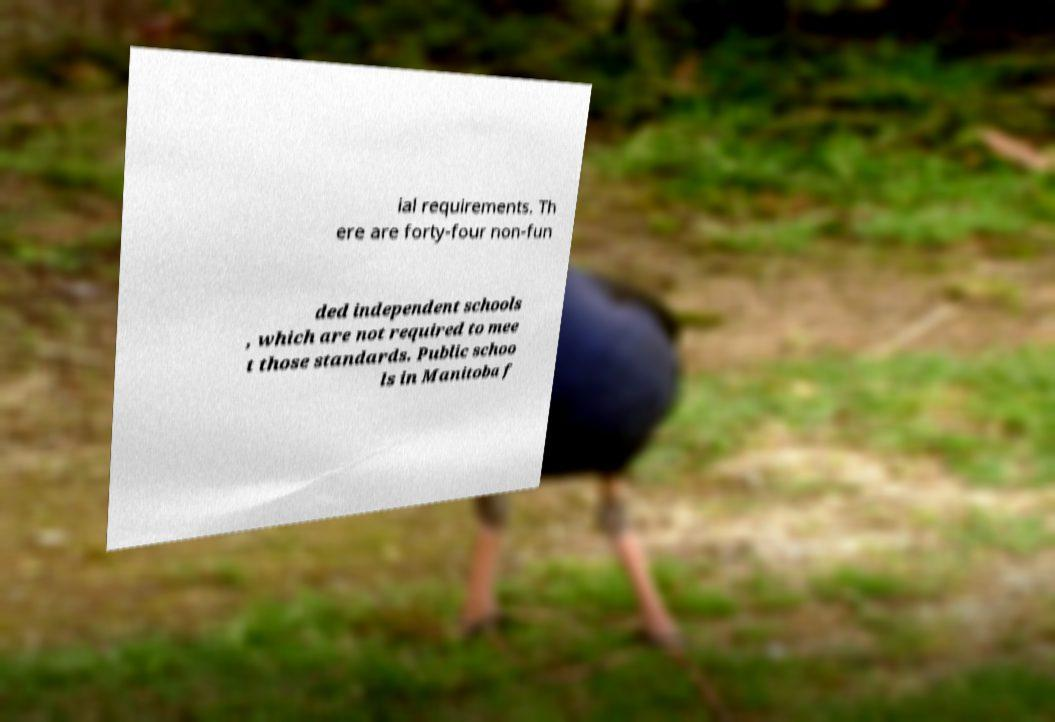There's text embedded in this image that I need extracted. Can you transcribe it verbatim? ial requirements. Th ere are forty-four non-fun ded independent schools , which are not required to mee t those standards. Public schoo ls in Manitoba f 